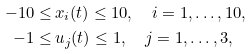<formula> <loc_0><loc_0><loc_500><loc_500>- 1 0 \leq & \, x _ { i } ( t ) \leq 1 0 , \quad i = 1 , \dots , 1 0 , \\ - 1 \leq & \, u _ { j } ( t ) \leq 1 , \quad j = 1 , \dots , 3 ,</formula> 